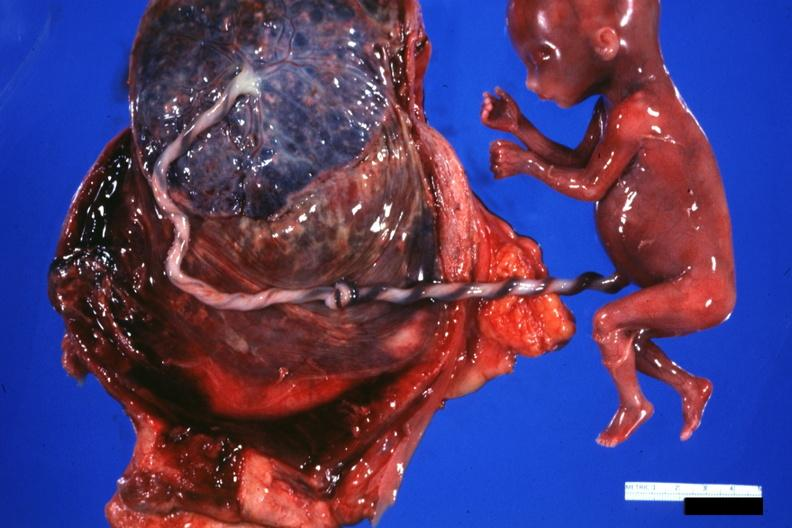what is present?
Answer the question using a single word or phrase. Umbilical cord 